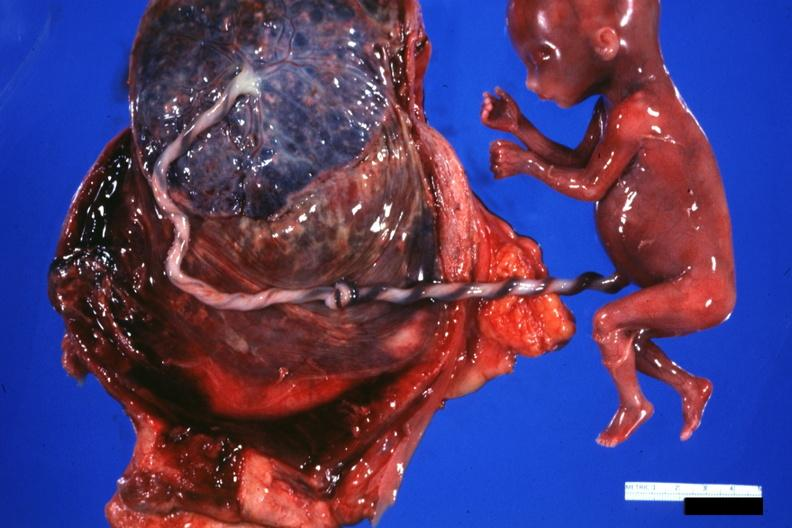what is present?
Answer the question using a single word or phrase. Umbilical cord 